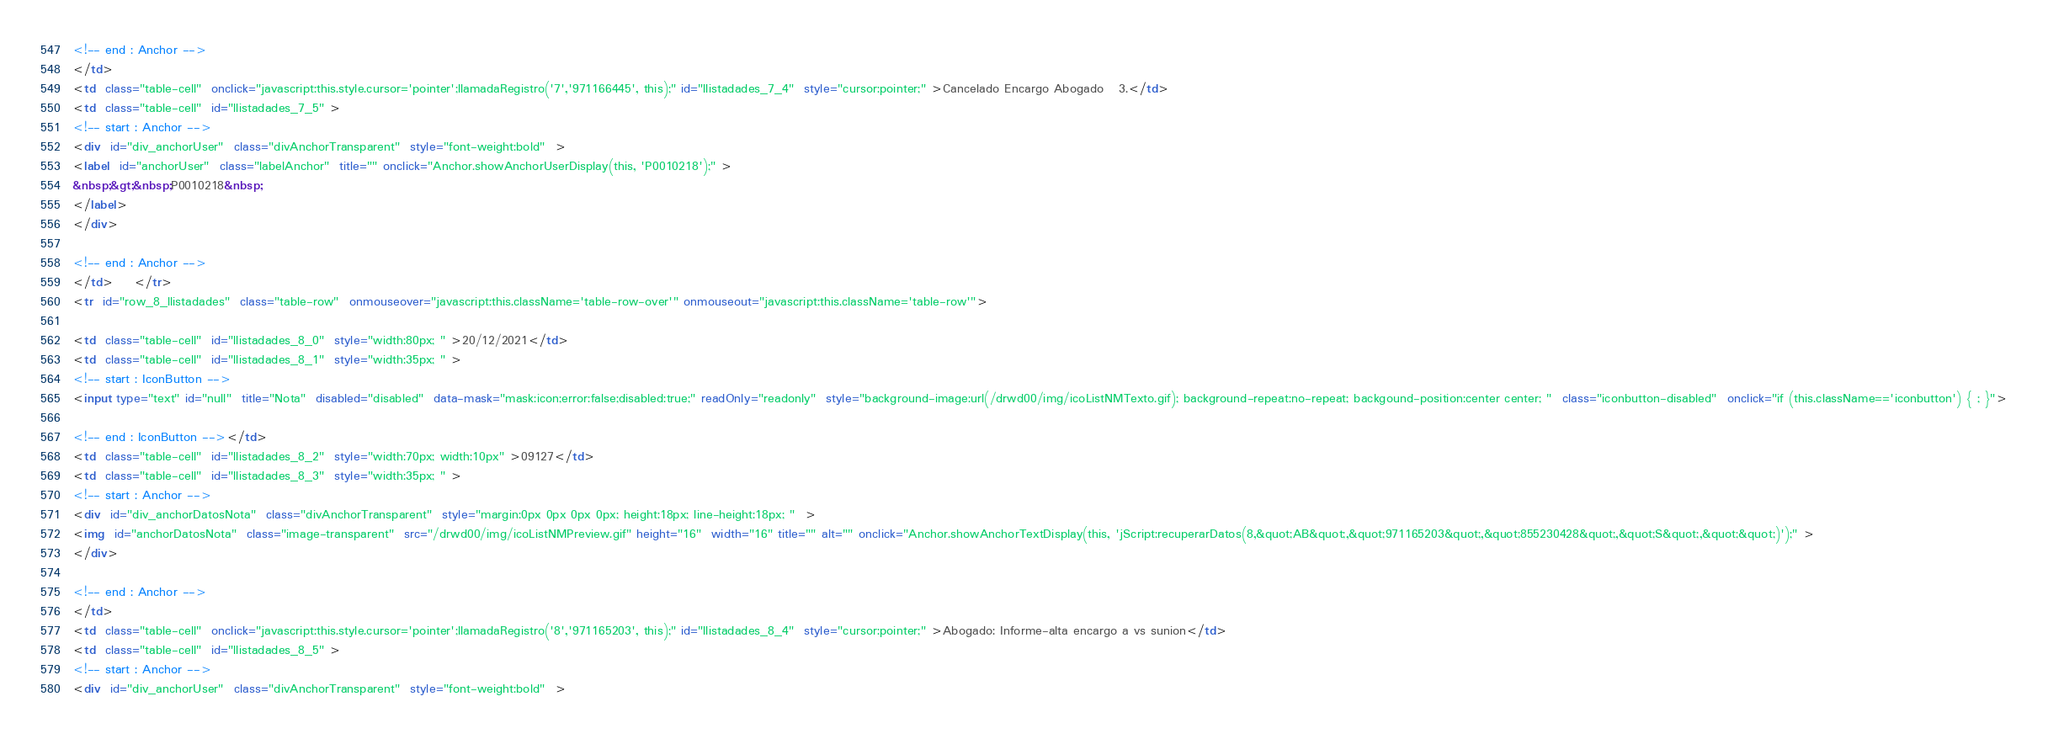Convert code to text. <code><loc_0><loc_0><loc_500><loc_500><_HTML_>
<!-- end : Anchor -->
</td>
<td  class="table-cell"  onclick="javascript:this.style.cursor='pointer';llamadaRegistro('7','971166445', this);" id="llistadades_7_4"  style="cursor:pointer;" >Cancelado Encargo Abogado   3.</td>
<td  class="table-cell"  id="llistadades_7_5" >
<!-- start : Anchor -->
<div  id="div_anchorUser"  class="divAnchorTransparent"  style="font-weight:bold"  >
<label  id="anchorUser"  class="labelAnchor"  title="" onclick="Anchor.showAnchorUserDisplay(this, 'P0010218');" >
&nbsp;&gt;&nbsp;P0010218&nbsp;
</label>
</div>

<!-- end : Anchor -->
</td>    </tr>
<tr  id="row_8_llistadades"  class="table-row"  onmouseover="javascript:this.className='table-row-over'" onmouseout="javascript:this.className='table-row'">

<td  class="table-cell"  id="llistadades_8_0"  style="width:80px; " >20/12/2021</td>
<td  class="table-cell"  id="llistadades_8_1"  style="width:35px; " >
<!-- start : IconButton -->
<input type="text" id="null"  title="Nota"  disabled="disabled"  data-mask="mask:icon;error:false;disabled:true;" readOnly="readonly"  style="background-image:url(/drwd00/img/icoListNMTexto.gif); background-repeat:no-repeat; backgound-position:center center; "  class="iconbutton-disabled"  onclick="if (this.className=='iconbutton') { ; }">

<!-- end : IconButton --></td>
<td  class="table-cell"  id="llistadades_8_2"  style="width:70px; width:10px" >09127</td>
<td  class="table-cell"  id="llistadades_8_3"  style="width:35px; " >
<!-- start : Anchor -->
<div  id="div_anchorDatosNota"  class="divAnchorTransparent"  style="margin:0px 0px 0px 0px; height:18px; line-height:18px; "  >
<img  id="anchorDatosNota"  class="image-transparent"  src="/drwd00/img/icoListNMPreview.gif" height="16"  width="16" title="" alt="" onclick="Anchor.showAnchorTextDisplay(this, 'jScript:recuperarDatos(8,&quot;AB&quot;,&quot;971165203&quot;,&quot;855230428&quot;,&quot;S&quot;,&quot;&quot;)');" >
</div>

<!-- end : Anchor -->
</td>
<td  class="table-cell"  onclick="javascript:this.style.cursor='pointer';llamadaRegistro('8','971165203', this);" id="llistadades_8_4"  style="cursor:pointer;" >Abogado: Informe-alta encargo a vs sunion</td>
<td  class="table-cell"  id="llistadades_8_5" >
<!-- start : Anchor -->
<div  id="div_anchorUser"  class="divAnchorTransparent"  style="font-weight:bold"  ></code> 